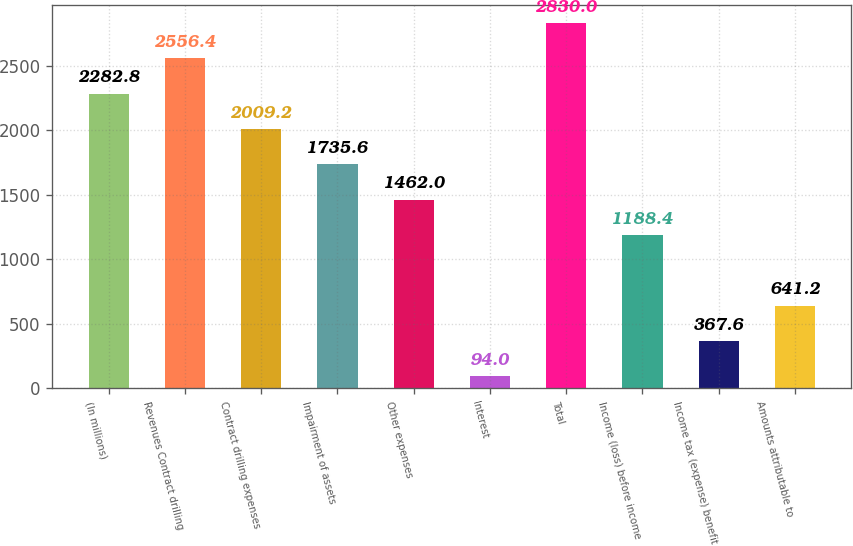<chart> <loc_0><loc_0><loc_500><loc_500><bar_chart><fcel>(In millions)<fcel>Revenues Contract drilling<fcel>Contract drilling expenses<fcel>Impairment of assets<fcel>Other expenses<fcel>Interest<fcel>Total<fcel>Income (loss) before income<fcel>Income tax (expense) benefit<fcel>Amounts attributable to<nl><fcel>2282.8<fcel>2556.4<fcel>2009.2<fcel>1735.6<fcel>1462<fcel>94<fcel>2830<fcel>1188.4<fcel>367.6<fcel>641.2<nl></chart> 